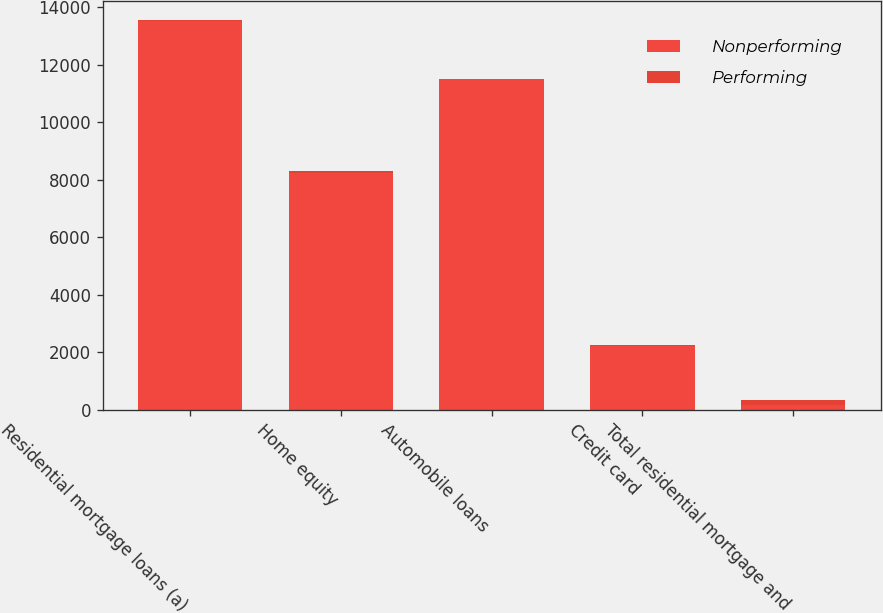Convert chart to OTSL. <chart><loc_0><loc_0><loc_500><loc_500><stacked_bar_chart><ecel><fcel>Residential mortgage loans (a)<fcel>Home equity<fcel>Automobile loans<fcel>Credit card<fcel>Total residential mortgage and<nl><fcel>Nonperforming<fcel>13498<fcel>8222<fcel>11491<fcel>2226<fcel>165<nl><fcel>Performing<fcel>51<fcel>79<fcel>2<fcel>33<fcel>165<nl></chart> 